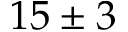Convert formula to latex. <formula><loc_0><loc_0><loc_500><loc_500>1 5 \pm 3</formula> 